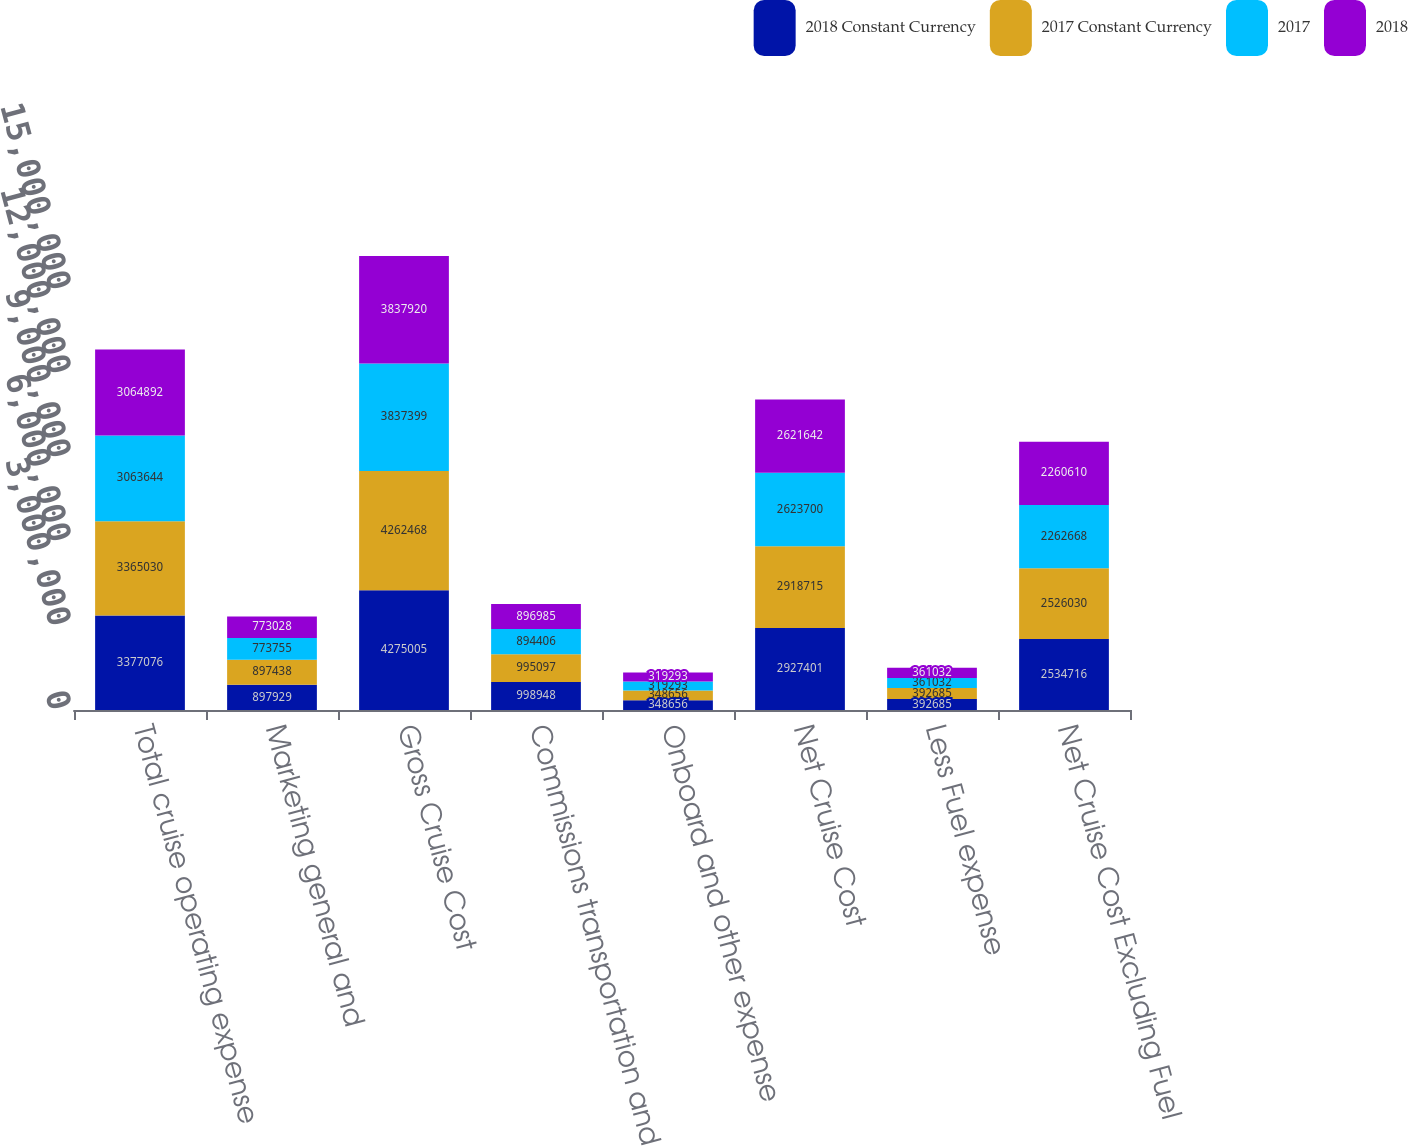Convert chart. <chart><loc_0><loc_0><loc_500><loc_500><stacked_bar_chart><ecel><fcel>Total cruise operating expense<fcel>Marketing general and<fcel>Gross Cruise Cost<fcel>Commissions transportation and<fcel>Onboard and other expense<fcel>Net Cruise Cost<fcel>Less Fuel expense<fcel>Net Cruise Cost Excluding Fuel<nl><fcel>2018 Constant Currency<fcel>3.37708e+06<fcel>897929<fcel>4.275e+06<fcel>998948<fcel>348656<fcel>2.9274e+06<fcel>392685<fcel>2.53472e+06<nl><fcel>2017 Constant Currency<fcel>3.36503e+06<fcel>897438<fcel>4.26247e+06<fcel>995097<fcel>348656<fcel>2.91872e+06<fcel>392685<fcel>2.52603e+06<nl><fcel>2017<fcel>3.06364e+06<fcel>773755<fcel>3.8374e+06<fcel>894406<fcel>319293<fcel>2.6237e+06<fcel>361032<fcel>2.26267e+06<nl><fcel>2018<fcel>3.06489e+06<fcel>773028<fcel>3.83792e+06<fcel>896985<fcel>319293<fcel>2.62164e+06<fcel>361032<fcel>2.26061e+06<nl></chart> 